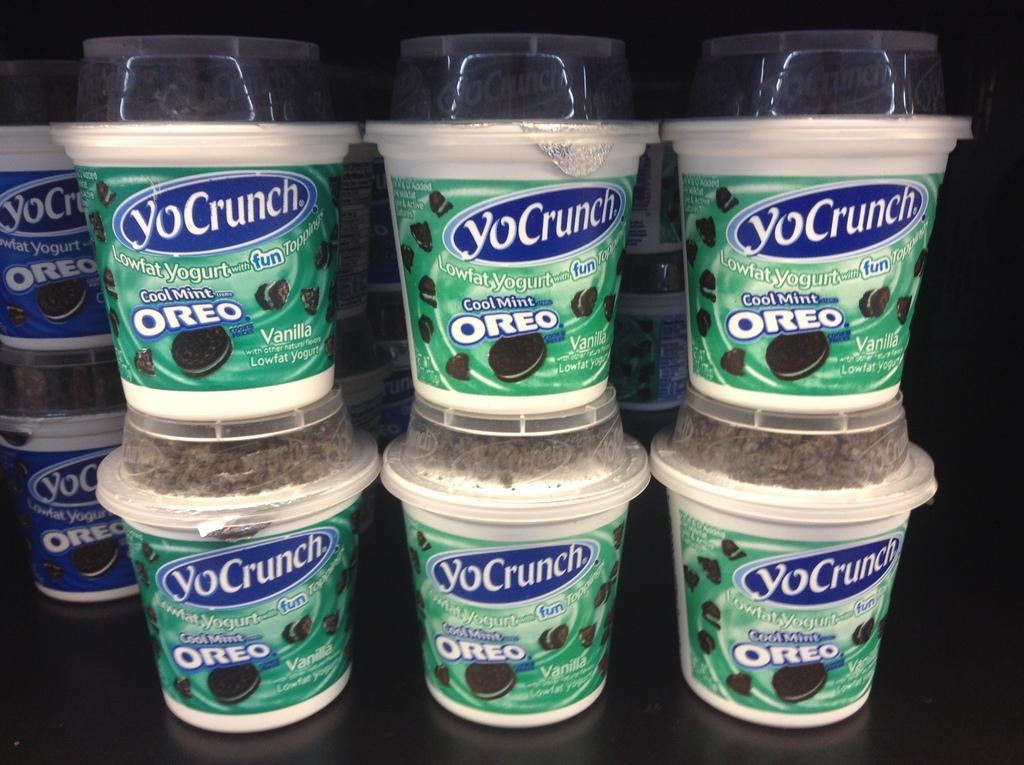What type of food cups are visible in the image? There are Oreo food cups in the image. Where are the Oreo food cups located? The Oreo food cups are on a surface. What journey did the sisters take with the metal Oreo food cups? There is no mention of sisters or a journey in the image, and the Oreo food cups are not described as being made of metal. 